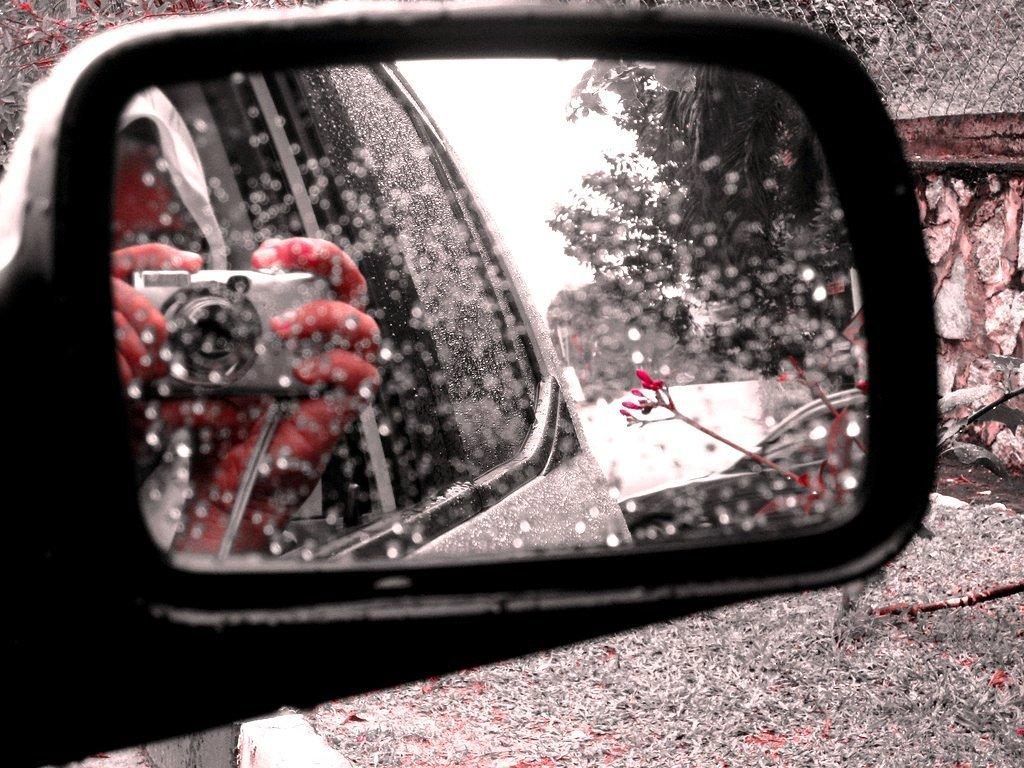What is the main subject of the image? The main subject of the image is a car mirror. What does the mirror reflect in the image? The mirror reflects a camera and a flower in the image. Are there any other parts of the car visible in the mirror? Yes, the windows of the car are reflected in the mirror. Can you see any bushes or a beast hiding behind the car in the image? No, there are no bushes or beasts visible in the image. The focus is on the car mirror and its reflections. 